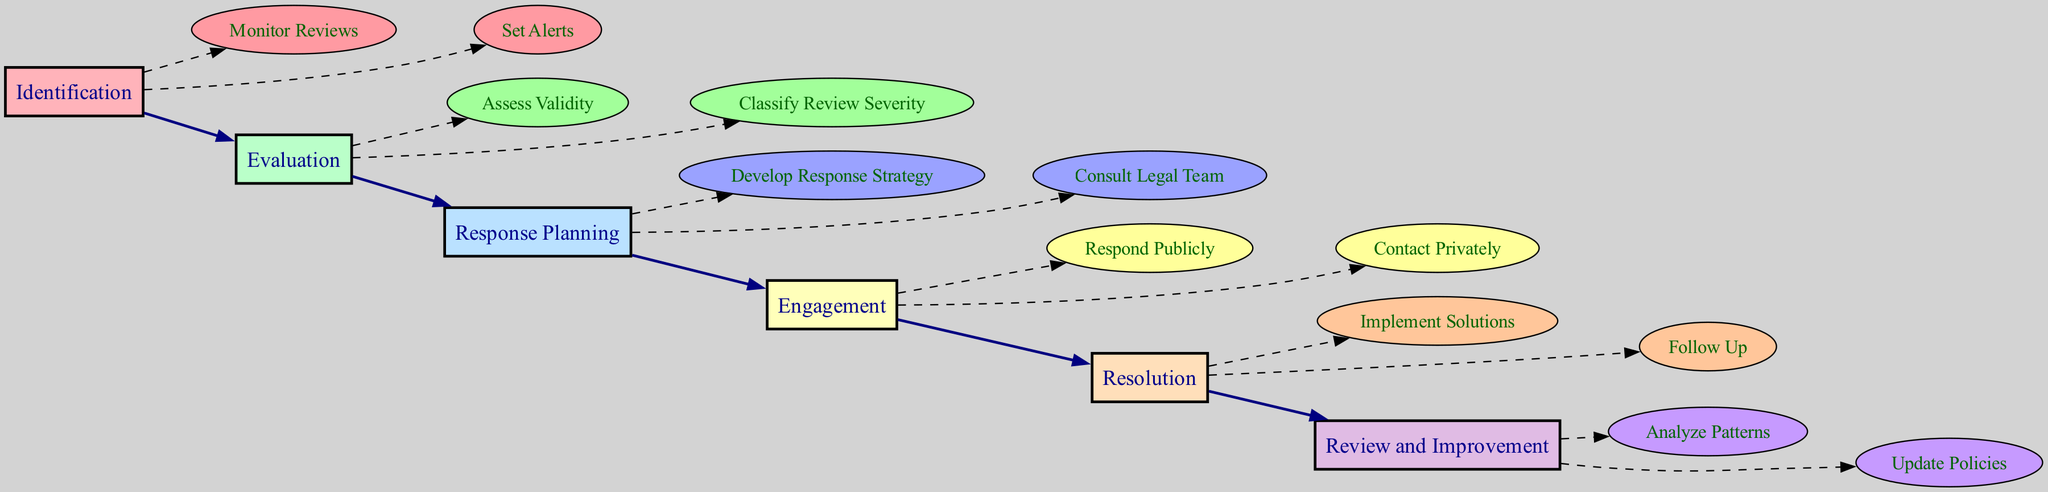What is the first stage in the clinical pathway? The first stage listed in the diagram is "Identification." This can be determined by looking at the order of the stages presented, where "Identification" is mentioned first.
Answer: Identification How many actions are included in the Evaluation stage? In the Evaluation stage, there are two actions: "Assess Validity" and "Classify Review Severity." This is found by counting the actions listed under the Evaluation stage.
Answer: 2 What is the color of the nodes in the Engagement stage? The engagement stage nodes are filled with a specific action color denoted in the diagram. They have an assigned color, which is a light shade of orange, identifiable as action colors in the diagram.
Answer: Light orange Which action follows "Contact Privately" in the clinical pathway? After "Contact Privately," there are no more actions in the Engagement stage since it is the last action listed in that stage. This requires examining the flow and structure of the nodes in that stage.
Answer: None What type of tools are suggested for the "Set Alerts" action? The "Set Alerts" action suggests tools like "Google Alerts" and "Social Mention." This is determined by reviewing the action details listed under the Identification stage.
Answer: Google Alerts, Social Mention What is the last stage in the clinical pathway? The last stage detailed in the diagram is "Review and Improvement." This can be identified by observing the sequence of stages presented in the diagram and noting the final one.
Answer: Review and Improvement How is the severity of a review categorized in the Evaluation stage? In the Evaluation stage, reviews are categorized as "Mild," "Moderate," or "Severe." This information is found directly under the action titled "Classify Review Severity."
Answer: Mild, Moderate, Severe What is one method of follow-up mentioned in the Resolution stage? One method of follow-up mentioned in the Resolution stage is "Phone Call." The follow-up methods are specified under the "Follow Up" action in the Resolution stage.
Answer: Phone Call 